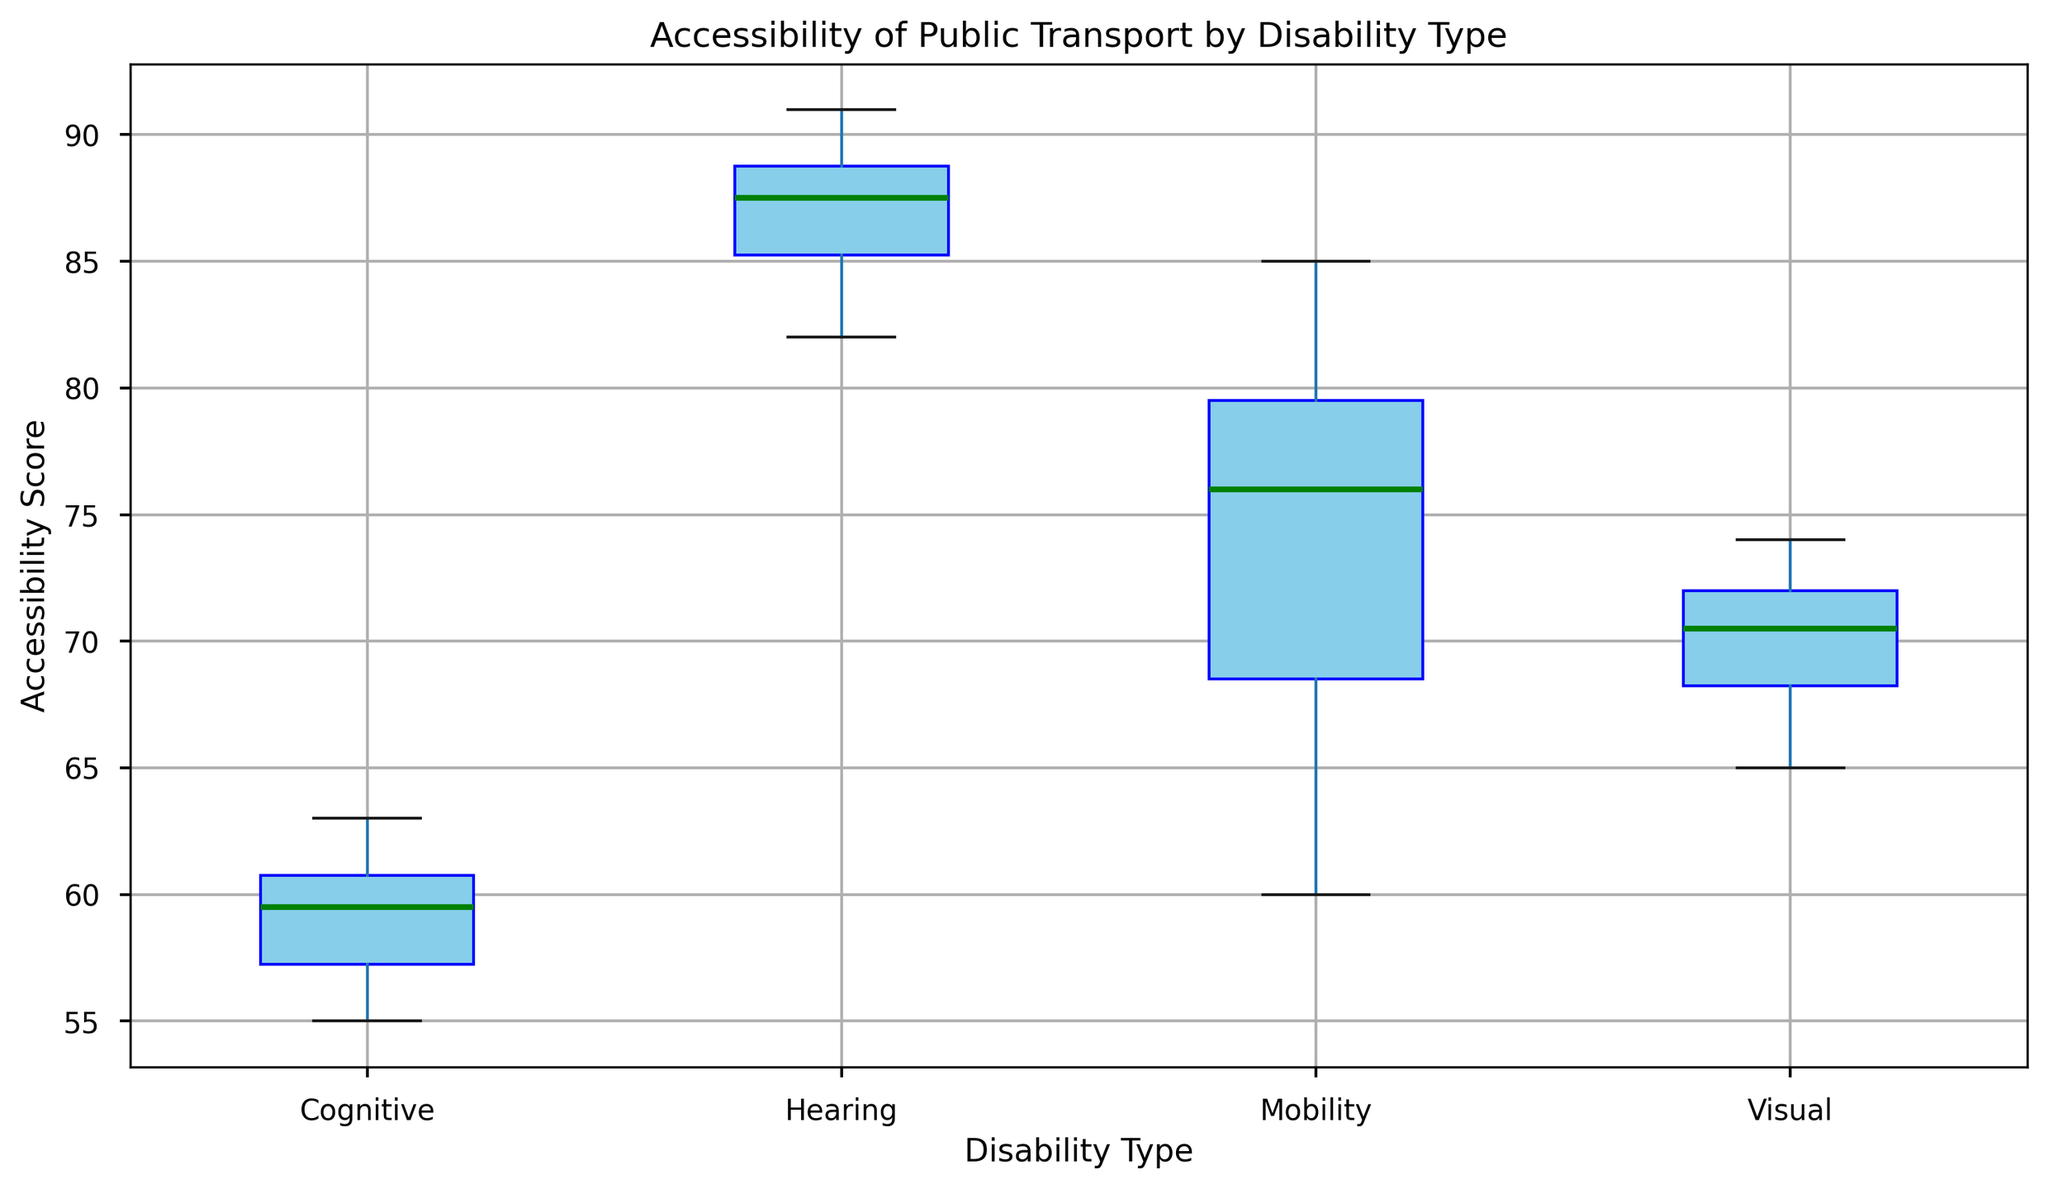What's the median value for each disability type? To determine the median value for each disability type, find the middle value of the ordered list of scores. If there is an even number of scores, the median is the average of the two middle numbers. For Mobility, it's the average of 75 and 77, so 76. For Hearing, it's 87.5 (average of 87 and 88). For Visual, it's 70.5 (average of 70 and 71). For Cognitive, it's 59.5 (average of 59 and 60).
Answer: Mobility: 76, Hearing: 87.5, Visual: 70.5, Cognitive: 59.5 Which disability type has the highest median accessibility score? By comparing the median values for each disability type, we see that Hearing has the highest median score of 87.5 among Mobility (76), Visual (70.5), and Cognitive (59.5).
Answer: Hearing Which group has the widest range of accessibility scores? The range is calculated by subtracting the minimum score from the maximum score in each group. By observing the plot, Mobility has the widest range from 60 to 85 (range = 25).
Answer: Mobility What is the interquartile range (IQR) for Visual disability? The IQR is found by subtracting the first quartile (Q1) value from the third quartile (Q3) value. For the Visual disability, Q3 is approximately 72 and Q1 is around 68, so the IQR is 72 - 68 = 4.
Answer: 4 Which disability type has the most consistent (least variable) accessibility scores? Consistency can be inferred from the length of the box in the box plot. Hearing shows the shortest box length, indicating the least variability among the other types.
Answer: Hearing What are the outliers for the Mobility group, if any? Outliers are data points that fall outside 1.5 times the IQR from the quartiles. In the box plot, there are no red markers (outliers) visible for Mobility, hence there are no outliers.
Answer: None How do the accessibility scores compare between Mobility and Cognitive disabilities? By comparing the boxes, Mobility has a higher median (76 vs. 59.5), higher overall scores with the range from 60 to 85, while Cognitive ranges from 55 to 63. Mobility shows higher accessibility scores compared to Cognitive.
Answer: Mobility scores higher Is there any overlap in the range of scores between Visual and Mobility disabilities? By observing the plot, Mobility ranges from 60 to 85, and Visual ranges from 65 to 74. The ranges overlap between 65 and 74.
Answer: Yes What's a unique attribute of the Hearing disability type's scores? Hearing has the highest median score (87.5) and the smallest range, indicating both high accessibility and consistency in accessibility scores.
Answer: High median and small range 